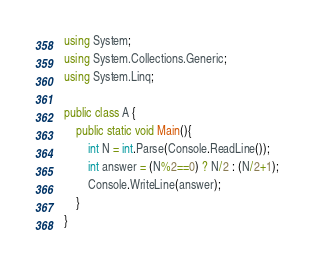<code> <loc_0><loc_0><loc_500><loc_500><_C#_>using System;
using System.Collections.Generic;
using System.Linq;
 
public class A {
    public static void Main(){
        int N = int.Parse(Console.ReadLine());
        int answer = (N%2==0) ? N/2 : (N/2+1);
        Console.WriteLine(answer);
    }
}</code> 